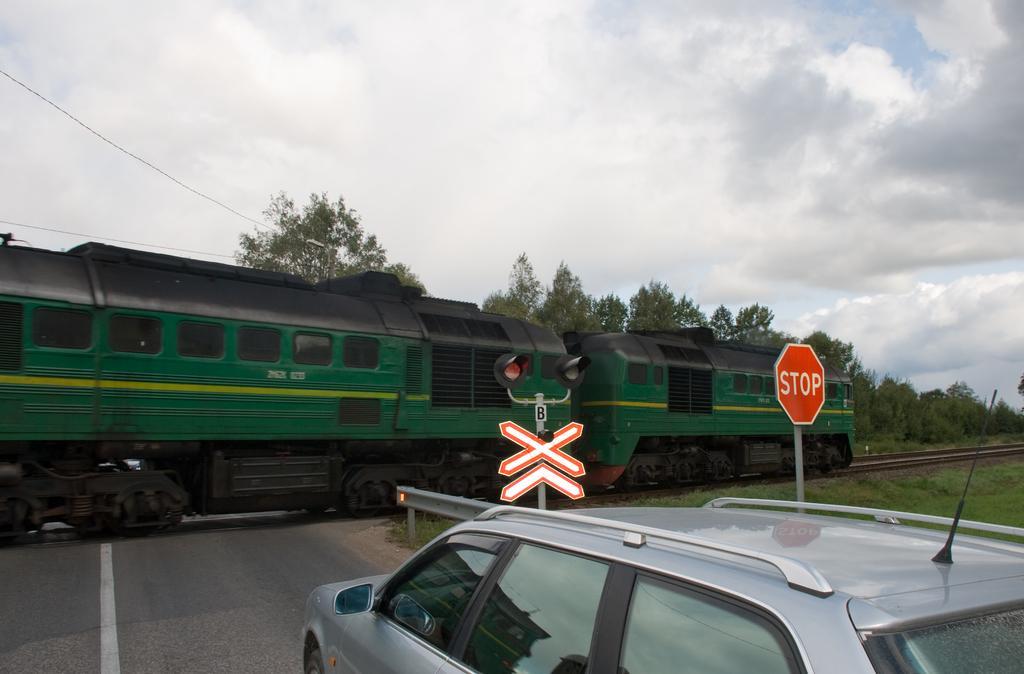Please provide a concise description of this image. In this image there is a car on the road and beside the car there is a signal and in front of the car there is a traffic signal. At the right side of the image there is a grass on the surface and at the back side there are trees and in the center there is a train on railway track and at the top of the image there is sky. 